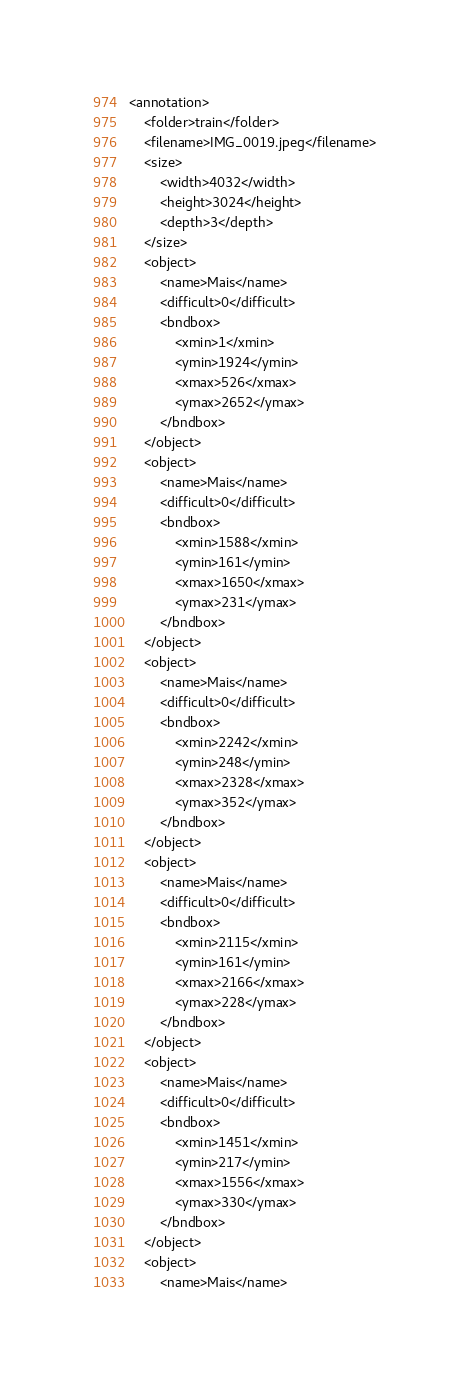Convert code to text. <code><loc_0><loc_0><loc_500><loc_500><_XML_><annotation>
    <folder>train</folder>
    <filename>IMG_0019.jpeg</filename>
    <size>
        <width>4032</width>
        <height>3024</height>
        <depth>3</depth>
    </size>
    <object>
        <name>Mais</name>
        <difficult>0</difficult>
        <bndbox>
            <xmin>1</xmin>
            <ymin>1924</ymin>
            <xmax>526</xmax>
            <ymax>2652</ymax>
        </bndbox>
    </object>
    <object>
        <name>Mais</name>
        <difficult>0</difficult>
        <bndbox>
            <xmin>1588</xmin>
            <ymin>161</ymin>
            <xmax>1650</xmax>
            <ymax>231</ymax>
        </bndbox>
    </object>
    <object>
        <name>Mais</name>
        <difficult>0</difficult>
        <bndbox>
            <xmin>2242</xmin>
            <ymin>248</ymin>
            <xmax>2328</xmax>
            <ymax>352</ymax>
        </bndbox>
    </object>
    <object>
        <name>Mais</name>
        <difficult>0</difficult>
        <bndbox>
            <xmin>2115</xmin>
            <ymin>161</ymin>
            <xmax>2166</xmax>
            <ymax>228</ymax>
        </bndbox>
    </object>
    <object>
        <name>Mais</name>
        <difficult>0</difficult>
        <bndbox>
            <xmin>1451</xmin>
            <ymin>217</ymin>
            <xmax>1556</xmax>
            <ymax>330</ymax>
        </bndbox>
    </object>
    <object>
        <name>Mais</name></code> 